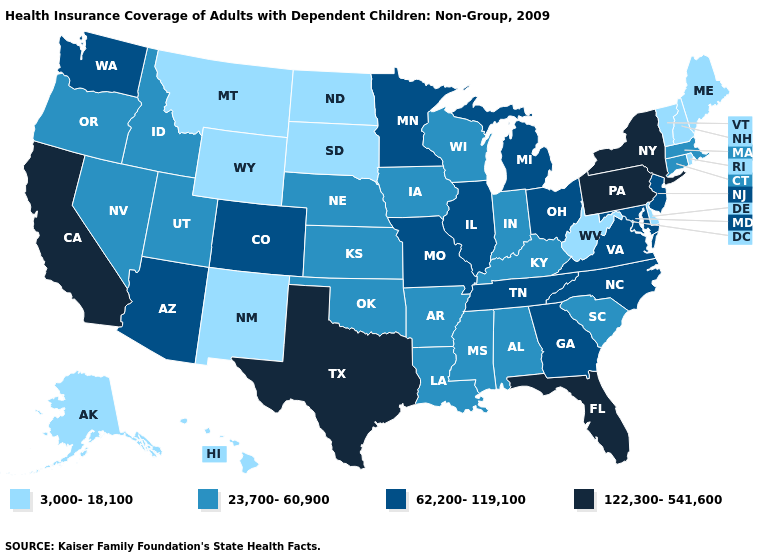What is the value of Missouri?
Short answer required. 62,200-119,100. Name the states that have a value in the range 62,200-119,100?
Quick response, please. Arizona, Colorado, Georgia, Illinois, Maryland, Michigan, Minnesota, Missouri, New Jersey, North Carolina, Ohio, Tennessee, Virginia, Washington. Name the states that have a value in the range 3,000-18,100?
Quick response, please. Alaska, Delaware, Hawaii, Maine, Montana, New Hampshire, New Mexico, North Dakota, Rhode Island, South Dakota, Vermont, West Virginia, Wyoming. What is the lowest value in the West?
Keep it brief. 3,000-18,100. Does Montana have a lower value than Alabama?
Write a very short answer. Yes. Among the states that border Florida , which have the highest value?
Be succinct. Georgia. What is the highest value in the USA?
Be succinct. 122,300-541,600. What is the value of Tennessee?
Answer briefly. 62,200-119,100. What is the value of Arizona?
Concise answer only. 62,200-119,100. Name the states that have a value in the range 3,000-18,100?
Keep it brief. Alaska, Delaware, Hawaii, Maine, Montana, New Hampshire, New Mexico, North Dakota, Rhode Island, South Dakota, Vermont, West Virginia, Wyoming. Which states have the lowest value in the USA?
Answer briefly. Alaska, Delaware, Hawaii, Maine, Montana, New Hampshire, New Mexico, North Dakota, Rhode Island, South Dakota, Vermont, West Virginia, Wyoming. What is the lowest value in the Northeast?
Give a very brief answer. 3,000-18,100. Among the states that border Colorado , which have the lowest value?
Short answer required. New Mexico, Wyoming. What is the value of Idaho?
Write a very short answer. 23,700-60,900. Name the states that have a value in the range 3,000-18,100?
Give a very brief answer. Alaska, Delaware, Hawaii, Maine, Montana, New Hampshire, New Mexico, North Dakota, Rhode Island, South Dakota, Vermont, West Virginia, Wyoming. 